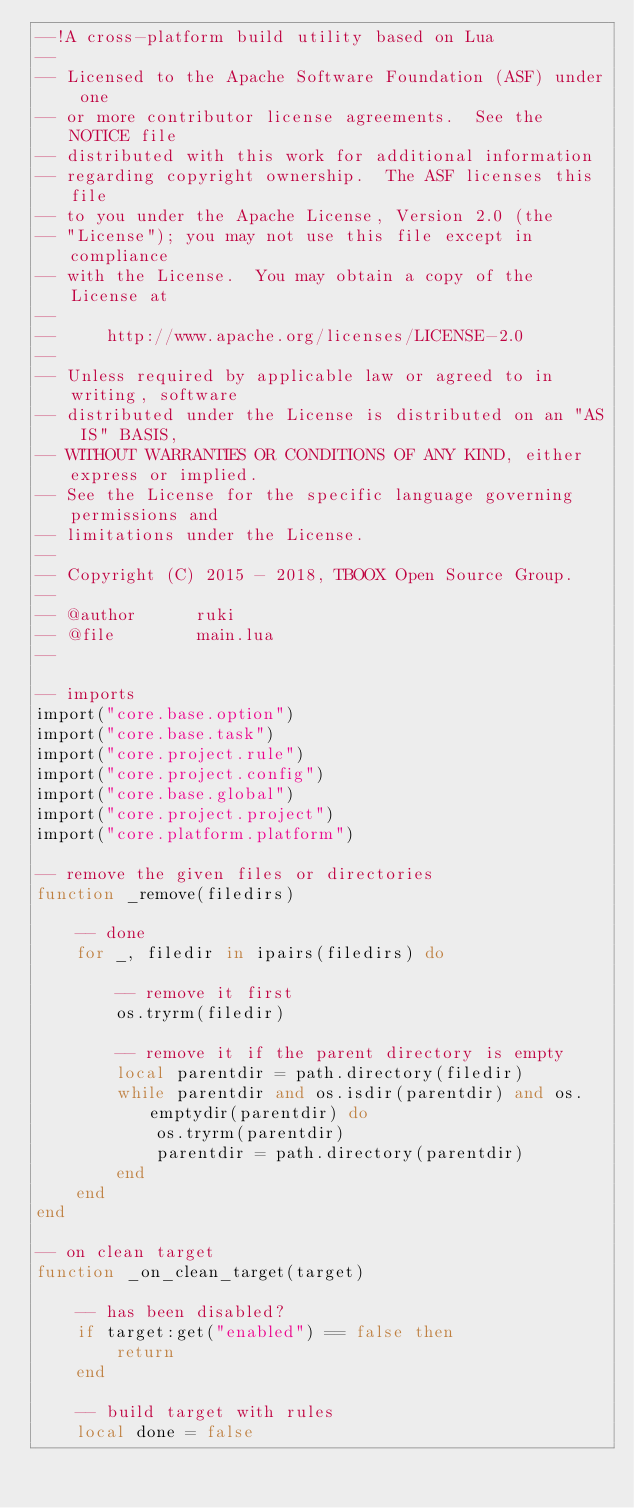<code> <loc_0><loc_0><loc_500><loc_500><_Lua_>--!A cross-platform build utility based on Lua
--
-- Licensed to the Apache Software Foundation (ASF) under one
-- or more contributor license agreements.  See the NOTICE file
-- distributed with this work for additional information
-- regarding copyright ownership.  The ASF licenses this file
-- to you under the Apache License, Version 2.0 (the
-- "License"); you may not use this file except in compliance
-- with the License.  You may obtain a copy of the License at
--
--     http://www.apache.org/licenses/LICENSE-2.0
--
-- Unless required by applicable law or agreed to in writing, software
-- distributed under the License is distributed on an "AS IS" BASIS,
-- WITHOUT WARRANTIES OR CONDITIONS OF ANY KIND, either express or implied.
-- See the License for the specific language governing permissions and
-- limitations under the License.
-- 
-- Copyright (C) 2015 - 2018, TBOOX Open Source Group.
--
-- @author      ruki
-- @file        main.lua
--

-- imports
import("core.base.option")
import("core.base.task")
import("core.project.rule")
import("core.project.config")
import("core.base.global")
import("core.project.project")
import("core.platform.platform")

-- remove the given files or directories
function _remove(filedirs)

    -- done
    for _, filedir in ipairs(filedirs) do

        -- remove it first
        os.tryrm(filedir)
 
        -- remove it if the parent directory is empty
        local parentdir = path.directory(filedir)
        while parentdir and os.isdir(parentdir) and os.emptydir(parentdir) do
            os.tryrm(parentdir)
            parentdir = path.directory(parentdir)
        end
    end
end

-- on clean target 
function _on_clean_target(target)

    -- has been disabled?
    if target:get("enabled") == false then
        return 
    end

    -- build target with rules
    local done = false</code> 